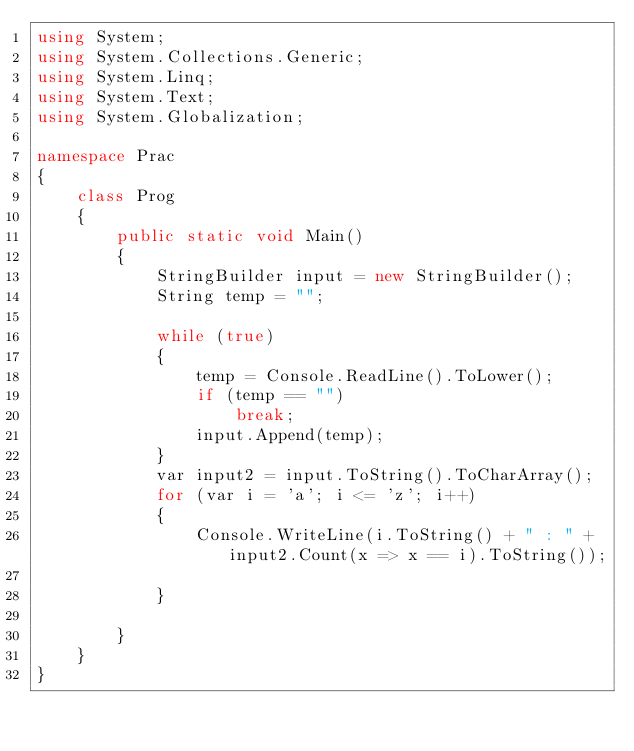Convert code to text. <code><loc_0><loc_0><loc_500><loc_500><_C#_>using System;
using System.Collections.Generic;
using System.Linq;
using System.Text;
using System.Globalization;

namespace Prac
{
    class Prog
    {
        public static void Main()
        {
            StringBuilder input = new StringBuilder();
            String temp = "";
          
            while (true)
            {
                temp = Console.ReadLine().ToLower();
                if (temp == "")
                    break;
                input.Append(temp);
            }
            var input2 = input.ToString().ToCharArray();
            for (var i = 'a'; i <= 'z'; i++)
            {
                Console.WriteLine(i.ToString() + " : " + input2.Count(x => x == i).ToString());
                
            }
           
        }
    }
}</code> 